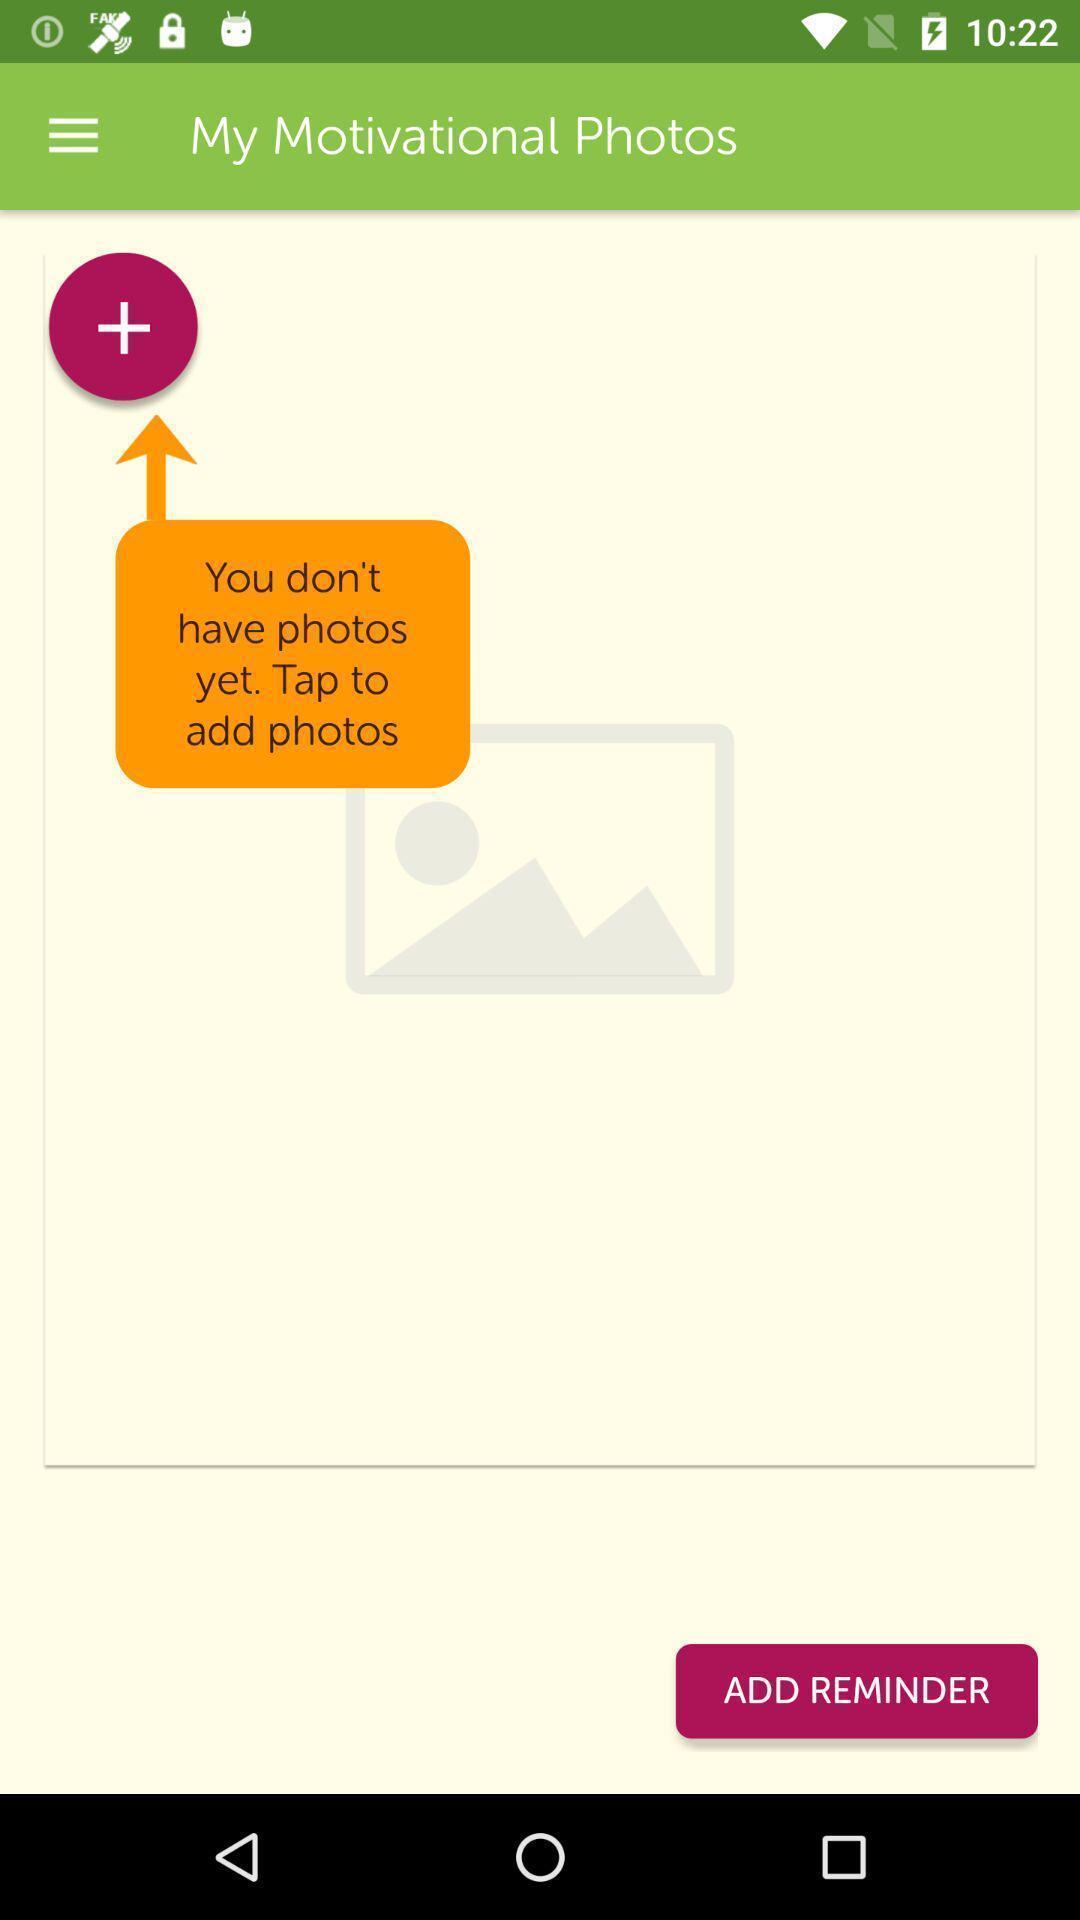What details can you identify in this image? Screen shows add motivational photos page in diet application. 